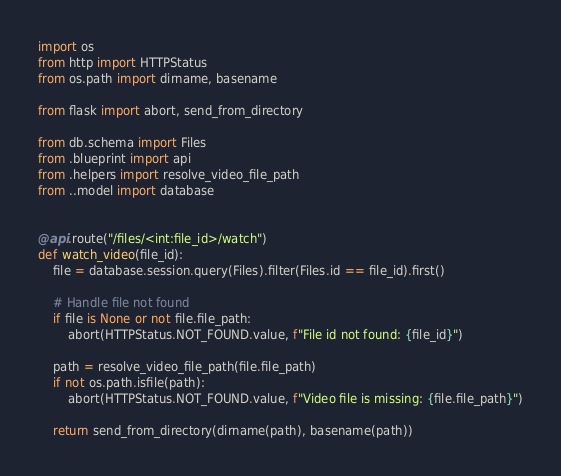<code> <loc_0><loc_0><loc_500><loc_500><_Python_>import os
from http import HTTPStatus
from os.path import dirname, basename

from flask import abort, send_from_directory

from db.schema import Files
from .blueprint import api
from .helpers import resolve_video_file_path
from ..model import database


@api.route("/files/<int:file_id>/watch")
def watch_video(file_id):
    file = database.session.query(Files).filter(Files.id == file_id).first()

    # Handle file not found
    if file is None or not file.file_path:
        abort(HTTPStatus.NOT_FOUND.value, f"File id not found: {file_id}")

    path = resolve_video_file_path(file.file_path)
    if not os.path.isfile(path):
        abort(HTTPStatus.NOT_FOUND.value, f"Video file is missing: {file.file_path}")

    return send_from_directory(dirname(path), basename(path))
</code> 